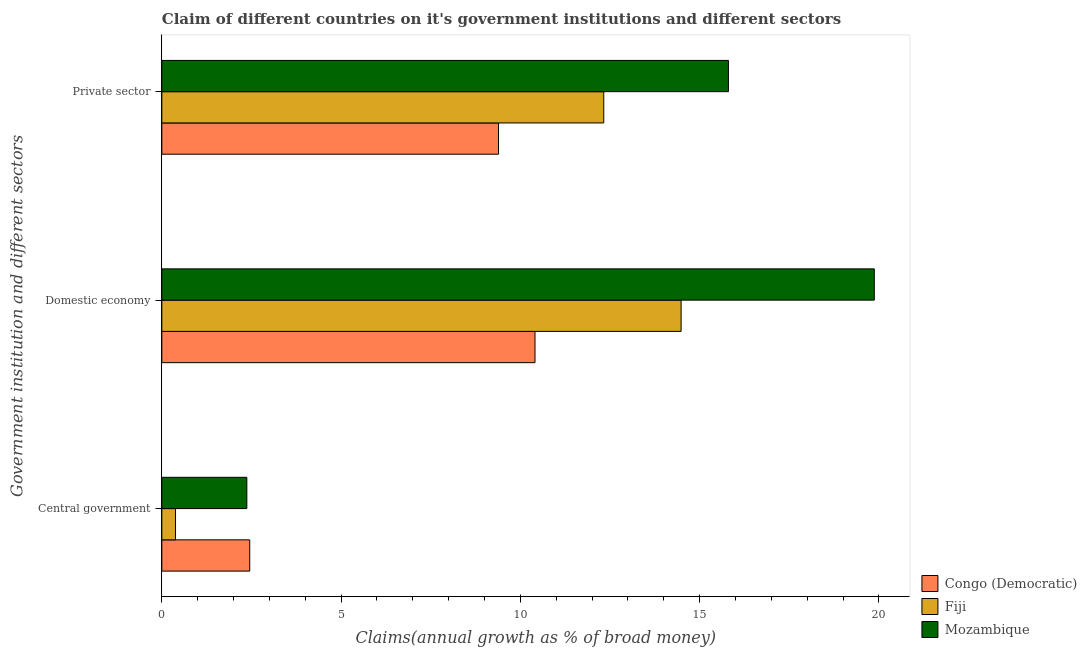Are the number of bars on each tick of the Y-axis equal?
Your answer should be compact. Yes. What is the label of the 1st group of bars from the top?
Keep it short and to the point. Private sector. What is the percentage of claim on the private sector in Congo (Democratic)?
Ensure brevity in your answer.  9.39. Across all countries, what is the maximum percentage of claim on the central government?
Provide a short and direct response. 2.45. Across all countries, what is the minimum percentage of claim on the domestic economy?
Your answer should be compact. 10.41. In which country was the percentage of claim on the private sector maximum?
Provide a succinct answer. Mozambique. In which country was the percentage of claim on the domestic economy minimum?
Give a very brief answer. Congo (Democratic). What is the total percentage of claim on the private sector in the graph?
Offer a terse response. 37.52. What is the difference between the percentage of claim on the domestic economy in Fiji and that in Mozambique?
Make the answer very short. -5.39. What is the difference between the percentage of claim on the domestic economy in Congo (Democratic) and the percentage of claim on the central government in Fiji?
Make the answer very short. 10.03. What is the average percentage of claim on the private sector per country?
Your answer should be very brief. 12.51. What is the difference between the percentage of claim on the central government and percentage of claim on the private sector in Mozambique?
Ensure brevity in your answer.  -13.43. What is the ratio of the percentage of claim on the domestic economy in Fiji to that in Congo (Democratic)?
Provide a succinct answer. 1.39. Is the difference between the percentage of claim on the domestic economy in Congo (Democratic) and Mozambique greater than the difference between the percentage of claim on the private sector in Congo (Democratic) and Mozambique?
Offer a very short reply. No. What is the difference between the highest and the second highest percentage of claim on the central government?
Keep it short and to the point. 0.08. What is the difference between the highest and the lowest percentage of claim on the central government?
Offer a terse response. 2.07. In how many countries, is the percentage of claim on the central government greater than the average percentage of claim on the central government taken over all countries?
Keep it short and to the point. 2. Is the sum of the percentage of claim on the central government in Mozambique and Fiji greater than the maximum percentage of claim on the private sector across all countries?
Make the answer very short. No. What does the 1st bar from the top in Domestic economy represents?
Your answer should be compact. Mozambique. What does the 2nd bar from the bottom in Domestic economy represents?
Your response must be concise. Fiji. How many bars are there?
Ensure brevity in your answer.  9. Are all the bars in the graph horizontal?
Provide a short and direct response. Yes. What is the difference between two consecutive major ticks on the X-axis?
Your answer should be very brief. 5. Does the graph contain any zero values?
Offer a very short reply. No. Does the graph contain grids?
Offer a terse response. No. How are the legend labels stacked?
Your answer should be very brief. Vertical. What is the title of the graph?
Provide a short and direct response. Claim of different countries on it's government institutions and different sectors. What is the label or title of the X-axis?
Your answer should be very brief. Claims(annual growth as % of broad money). What is the label or title of the Y-axis?
Provide a succinct answer. Government institution and different sectors. What is the Claims(annual growth as % of broad money) in Congo (Democratic) in Central government?
Offer a very short reply. 2.45. What is the Claims(annual growth as % of broad money) of Fiji in Central government?
Your response must be concise. 0.38. What is the Claims(annual growth as % of broad money) in Mozambique in Central government?
Ensure brevity in your answer.  2.37. What is the Claims(annual growth as % of broad money) in Congo (Democratic) in Domestic economy?
Make the answer very short. 10.41. What is the Claims(annual growth as % of broad money) of Fiji in Domestic economy?
Ensure brevity in your answer.  14.48. What is the Claims(annual growth as % of broad money) of Mozambique in Domestic economy?
Offer a terse response. 19.87. What is the Claims(annual growth as % of broad money) in Congo (Democratic) in Private sector?
Make the answer very short. 9.39. What is the Claims(annual growth as % of broad money) of Fiji in Private sector?
Keep it short and to the point. 12.33. What is the Claims(annual growth as % of broad money) of Mozambique in Private sector?
Your answer should be very brief. 15.8. Across all Government institution and different sectors, what is the maximum Claims(annual growth as % of broad money) of Congo (Democratic)?
Your response must be concise. 10.41. Across all Government institution and different sectors, what is the maximum Claims(annual growth as % of broad money) in Fiji?
Offer a very short reply. 14.48. Across all Government institution and different sectors, what is the maximum Claims(annual growth as % of broad money) in Mozambique?
Provide a succinct answer. 19.87. Across all Government institution and different sectors, what is the minimum Claims(annual growth as % of broad money) of Congo (Democratic)?
Keep it short and to the point. 2.45. Across all Government institution and different sectors, what is the minimum Claims(annual growth as % of broad money) of Fiji?
Your answer should be very brief. 0.38. Across all Government institution and different sectors, what is the minimum Claims(annual growth as % of broad money) of Mozambique?
Provide a short and direct response. 2.37. What is the total Claims(annual growth as % of broad money) in Congo (Democratic) in the graph?
Keep it short and to the point. 22.25. What is the total Claims(annual growth as % of broad money) of Fiji in the graph?
Offer a very short reply. 27.19. What is the total Claims(annual growth as % of broad money) of Mozambique in the graph?
Offer a very short reply. 38.04. What is the difference between the Claims(annual growth as % of broad money) in Congo (Democratic) in Central government and that in Domestic economy?
Provide a succinct answer. -7.96. What is the difference between the Claims(annual growth as % of broad money) in Fiji in Central government and that in Domestic economy?
Make the answer very short. -14.1. What is the difference between the Claims(annual growth as % of broad money) in Mozambique in Central government and that in Domestic economy?
Provide a short and direct response. -17.5. What is the difference between the Claims(annual growth as % of broad money) of Congo (Democratic) in Central government and that in Private sector?
Give a very brief answer. -6.94. What is the difference between the Claims(annual growth as % of broad money) of Fiji in Central government and that in Private sector?
Make the answer very short. -11.94. What is the difference between the Claims(annual growth as % of broad money) in Mozambique in Central government and that in Private sector?
Provide a short and direct response. -13.43. What is the difference between the Claims(annual growth as % of broad money) of Congo (Democratic) in Domestic economy and that in Private sector?
Your answer should be compact. 1.02. What is the difference between the Claims(annual growth as % of broad money) of Fiji in Domestic economy and that in Private sector?
Offer a very short reply. 2.16. What is the difference between the Claims(annual growth as % of broad money) of Mozambique in Domestic economy and that in Private sector?
Your answer should be compact. 4.07. What is the difference between the Claims(annual growth as % of broad money) of Congo (Democratic) in Central government and the Claims(annual growth as % of broad money) of Fiji in Domestic economy?
Offer a terse response. -12.03. What is the difference between the Claims(annual growth as % of broad money) of Congo (Democratic) in Central government and the Claims(annual growth as % of broad money) of Mozambique in Domestic economy?
Make the answer very short. -17.42. What is the difference between the Claims(annual growth as % of broad money) in Fiji in Central government and the Claims(annual growth as % of broad money) in Mozambique in Domestic economy?
Offer a terse response. -19.49. What is the difference between the Claims(annual growth as % of broad money) of Congo (Democratic) in Central government and the Claims(annual growth as % of broad money) of Fiji in Private sector?
Give a very brief answer. -9.88. What is the difference between the Claims(annual growth as % of broad money) of Congo (Democratic) in Central government and the Claims(annual growth as % of broad money) of Mozambique in Private sector?
Offer a very short reply. -13.35. What is the difference between the Claims(annual growth as % of broad money) of Fiji in Central government and the Claims(annual growth as % of broad money) of Mozambique in Private sector?
Your answer should be very brief. -15.42. What is the difference between the Claims(annual growth as % of broad money) of Congo (Democratic) in Domestic economy and the Claims(annual growth as % of broad money) of Fiji in Private sector?
Your answer should be very brief. -1.92. What is the difference between the Claims(annual growth as % of broad money) of Congo (Democratic) in Domestic economy and the Claims(annual growth as % of broad money) of Mozambique in Private sector?
Provide a succinct answer. -5.39. What is the difference between the Claims(annual growth as % of broad money) in Fiji in Domestic economy and the Claims(annual growth as % of broad money) in Mozambique in Private sector?
Your answer should be compact. -1.32. What is the average Claims(annual growth as % of broad money) of Congo (Democratic) per Government institution and different sectors?
Provide a short and direct response. 7.42. What is the average Claims(annual growth as % of broad money) of Fiji per Government institution and different sectors?
Give a very brief answer. 9.06. What is the average Claims(annual growth as % of broad money) of Mozambique per Government institution and different sectors?
Your answer should be compact. 12.68. What is the difference between the Claims(annual growth as % of broad money) in Congo (Democratic) and Claims(annual growth as % of broad money) in Fiji in Central government?
Provide a short and direct response. 2.07. What is the difference between the Claims(annual growth as % of broad money) of Congo (Democratic) and Claims(annual growth as % of broad money) of Mozambique in Central government?
Keep it short and to the point. 0.08. What is the difference between the Claims(annual growth as % of broad money) of Fiji and Claims(annual growth as % of broad money) of Mozambique in Central government?
Give a very brief answer. -1.99. What is the difference between the Claims(annual growth as % of broad money) in Congo (Democratic) and Claims(annual growth as % of broad money) in Fiji in Domestic economy?
Your response must be concise. -4.08. What is the difference between the Claims(annual growth as % of broad money) in Congo (Democratic) and Claims(annual growth as % of broad money) in Mozambique in Domestic economy?
Provide a short and direct response. -9.46. What is the difference between the Claims(annual growth as % of broad money) of Fiji and Claims(annual growth as % of broad money) of Mozambique in Domestic economy?
Keep it short and to the point. -5.39. What is the difference between the Claims(annual growth as % of broad money) in Congo (Democratic) and Claims(annual growth as % of broad money) in Fiji in Private sector?
Ensure brevity in your answer.  -2.94. What is the difference between the Claims(annual growth as % of broad money) of Congo (Democratic) and Claims(annual growth as % of broad money) of Mozambique in Private sector?
Make the answer very short. -6.41. What is the difference between the Claims(annual growth as % of broad money) of Fiji and Claims(annual growth as % of broad money) of Mozambique in Private sector?
Provide a succinct answer. -3.48. What is the ratio of the Claims(annual growth as % of broad money) of Congo (Democratic) in Central government to that in Domestic economy?
Your answer should be compact. 0.24. What is the ratio of the Claims(annual growth as % of broad money) of Fiji in Central government to that in Domestic economy?
Ensure brevity in your answer.  0.03. What is the ratio of the Claims(annual growth as % of broad money) in Mozambique in Central government to that in Domestic economy?
Keep it short and to the point. 0.12. What is the ratio of the Claims(annual growth as % of broad money) of Congo (Democratic) in Central government to that in Private sector?
Give a very brief answer. 0.26. What is the ratio of the Claims(annual growth as % of broad money) in Fiji in Central government to that in Private sector?
Give a very brief answer. 0.03. What is the ratio of the Claims(annual growth as % of broad money) in Mozambique in Central government to that in Private sector?
Offer a terse response. 0.15. What is the ratio of the Claims(annual growth as % of broad money) of Congo (Democratic) in Domestic economy to that in Private sector?
Give a very brief answer. 1.11. What is the ratio of the Claims(annual growth as % of broad money) of Fiji in Domestic economy to that in Private sector?
Ensure brevity in your answer.  1.18. What is the ratio of the Claims(annual growth as % of broad money) of Mozambique in Domestic economy to that in Private sector?
Your answer should be compact. 1.26. What is the difference between the highest and the second highest Claims(annual growth as % of broad money) of Congo (Democratic)?
Provide a short and direct response. 1.02. What is the difference between the highest and the second highest Claims(annual growth as % of broad money) of Fiji?
Keep it short and to the point. 2.16. What is the difference between the highest and the second highest Claims(annual growth as % of broad money) of Mozambique?
Offer a terse response. 4.07. What is the difference between the highest and the lowest Claims(annual growth as % of broad money) in Congo (Democratic)?
Your answer should be very brief. 7.96. What is the difference between the highest and the lowest Claims(annual growth as % of broad money) in Fiji?
Keep it short and to the point. 14.1. What is the difference between the highest and the lowest Claims(annual growth as % of broad money) of Mozambique?
Offer a very short reply. 17.5. 